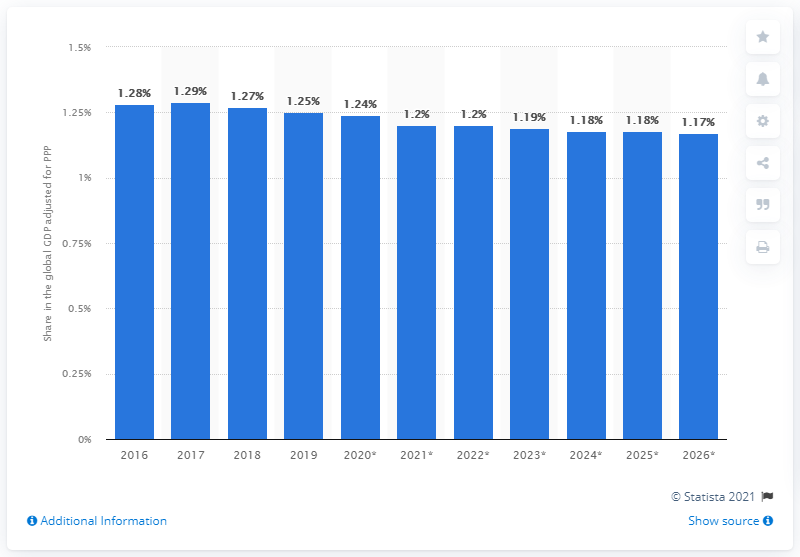Outline some significant characteristics in this image. According to a recent estimate, Saudi Arabia's share of the global GDP adjusted for purchasing power parity (PPP) in 2019 was approximately 1.24 times the share of the United States. 